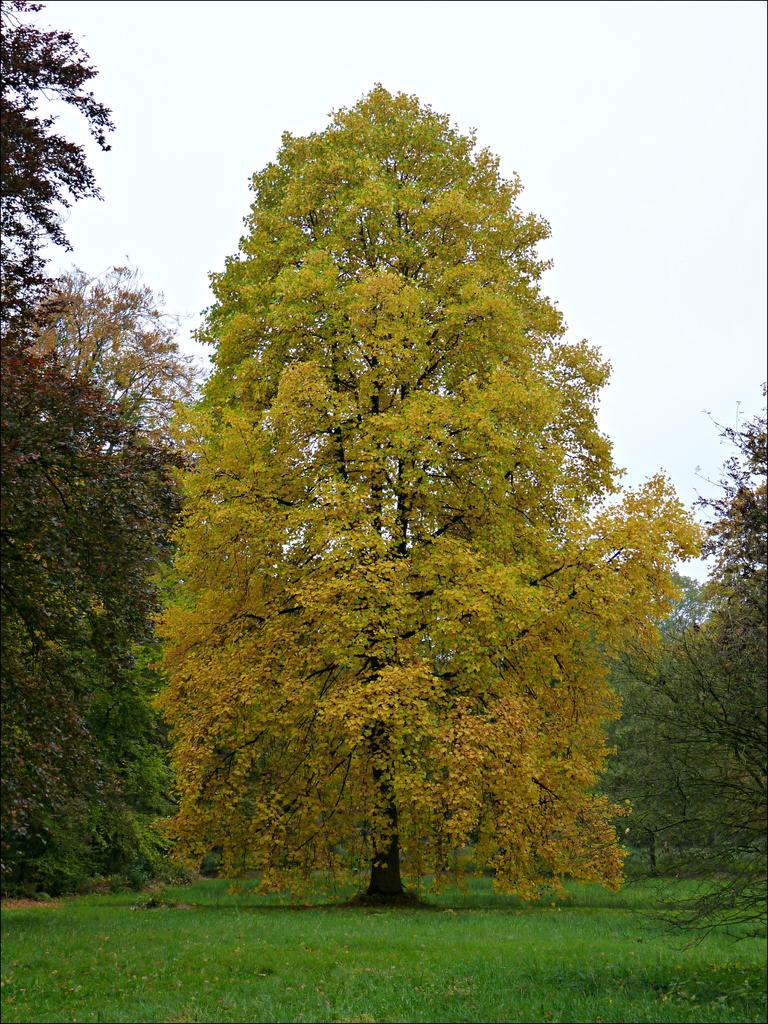What type of vegetation can be seen in the image? There are trees in the image. What else can be seen on the ground in the image? There is grass in the image. What is visible in the background of the image? The sky is visible in the image. What is the level of wealth displayed in the image? There is no indication of wealth in the image, as it features trees, grass, and the sky. 